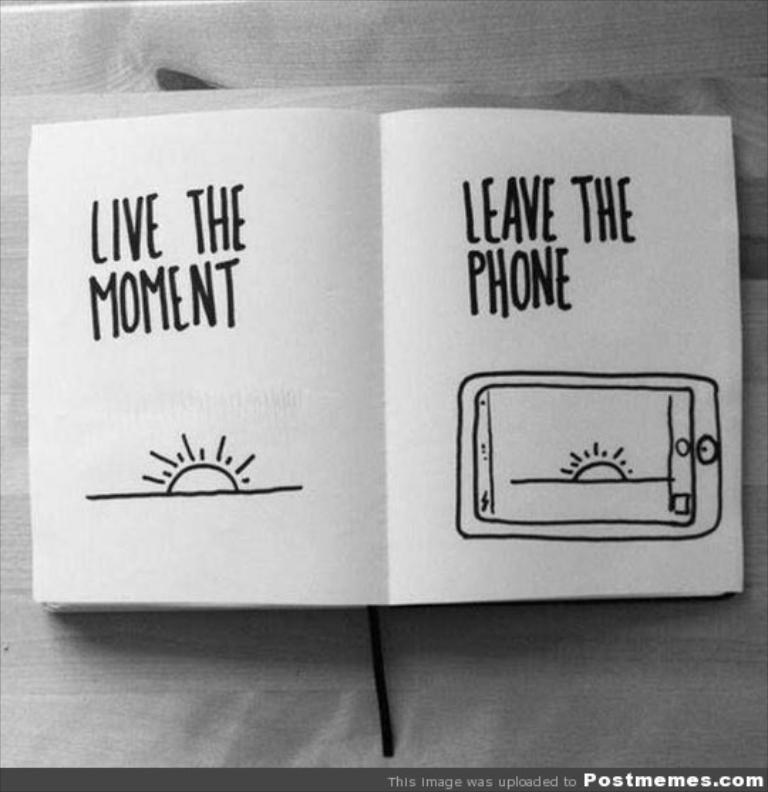<image>
Create a compact narrative representing the image presented. A book telling you to live the moment and leave the phone. 